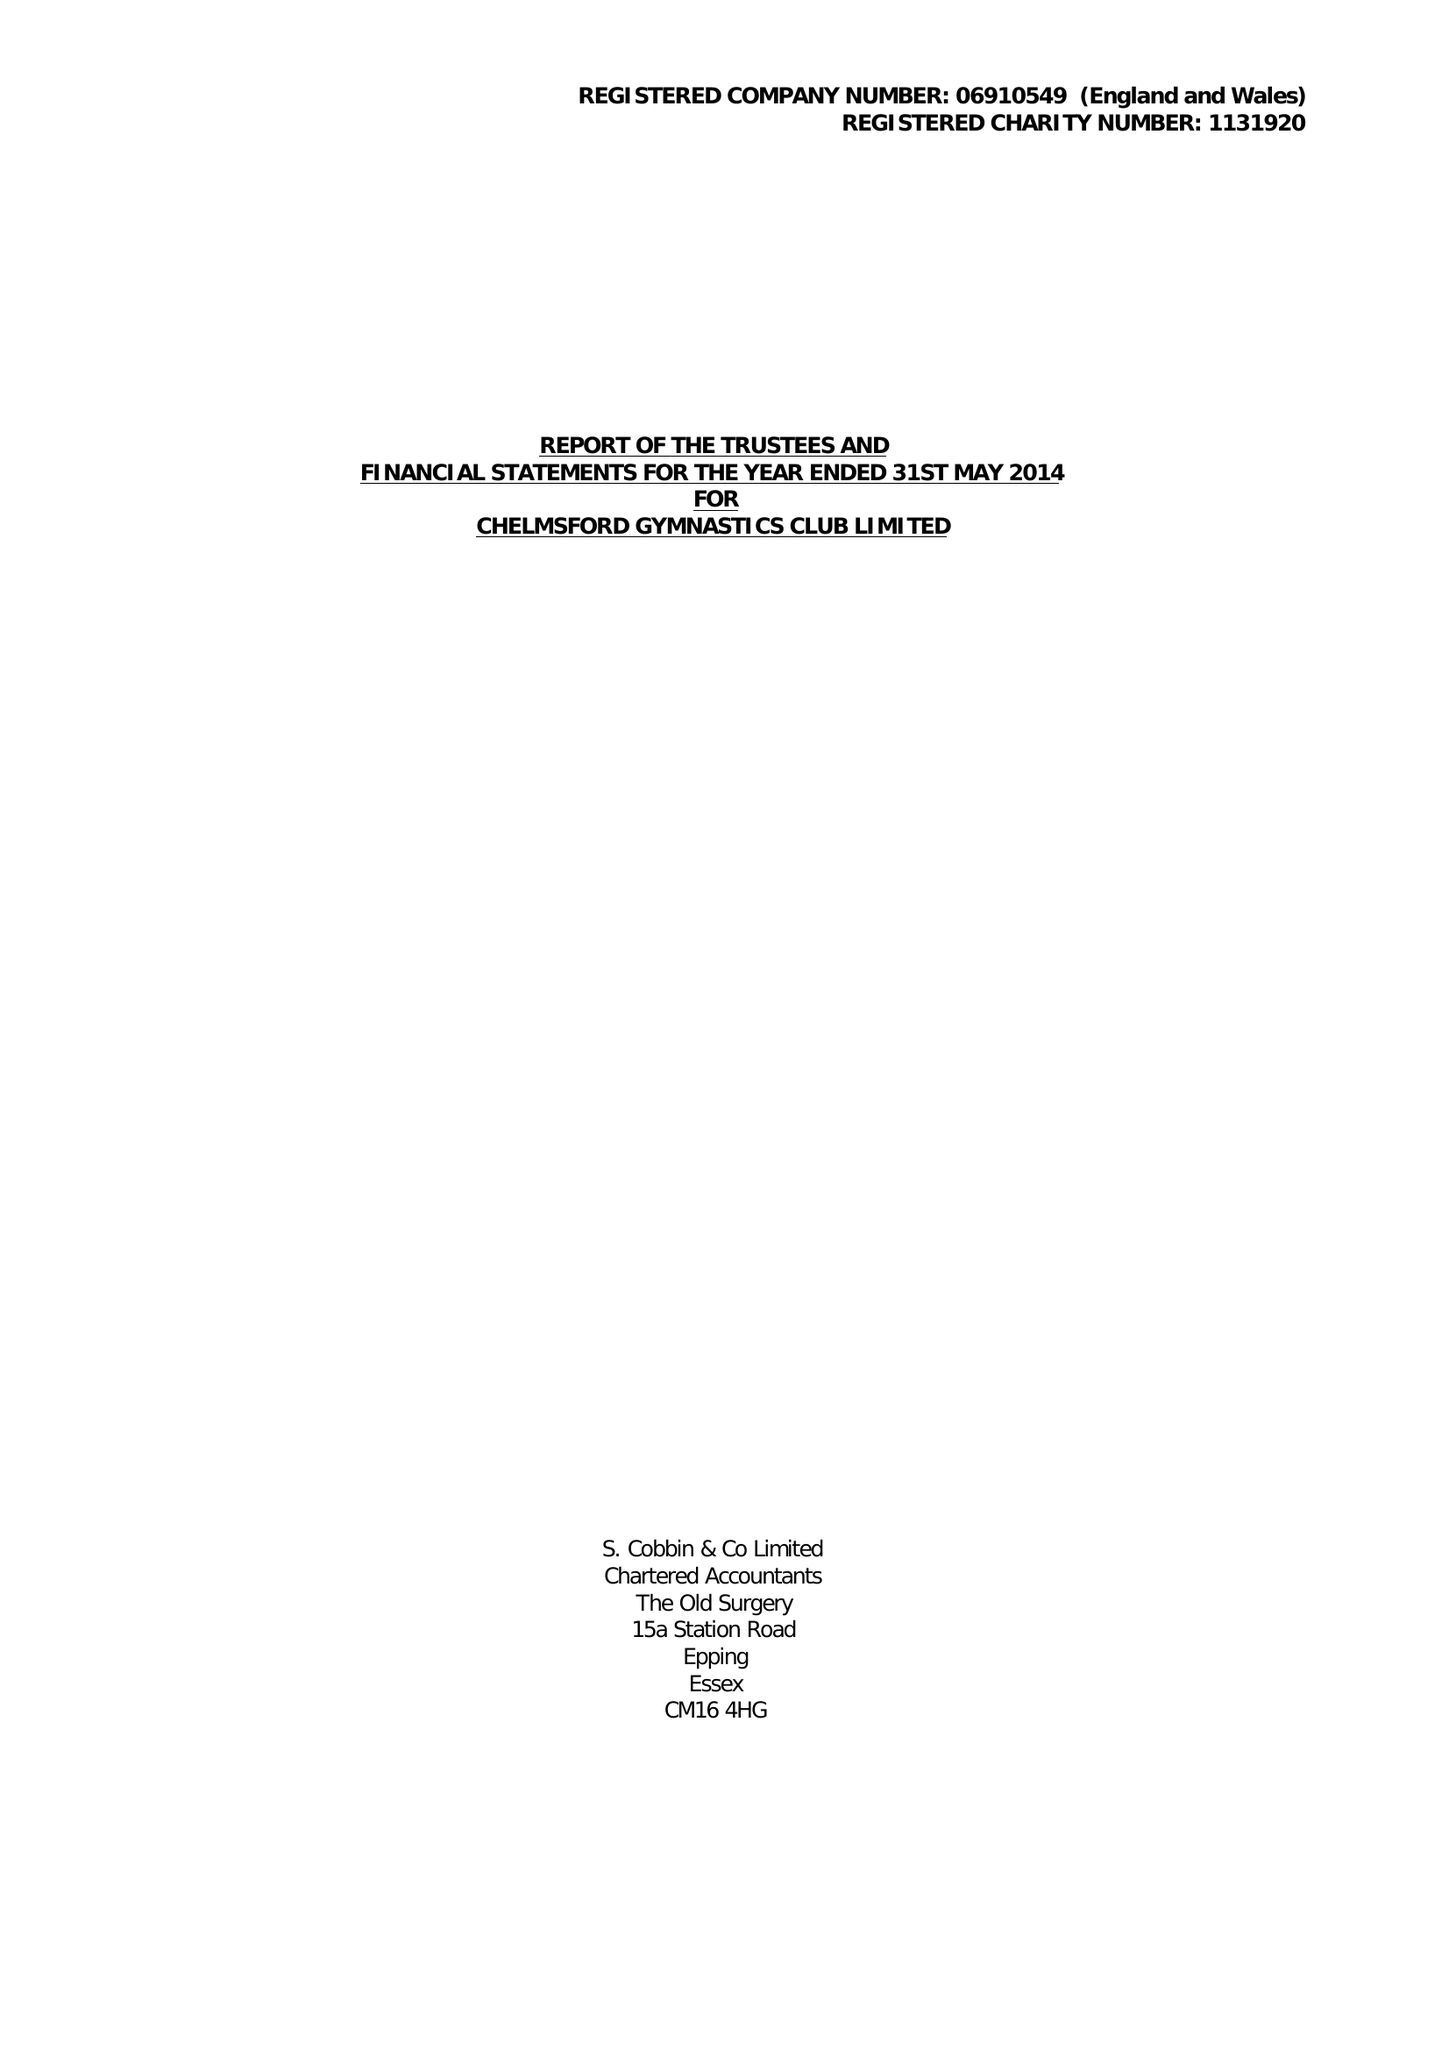What is the value for the address__postcode?
Answer the question using a single word or phrase. CM2 6BX 